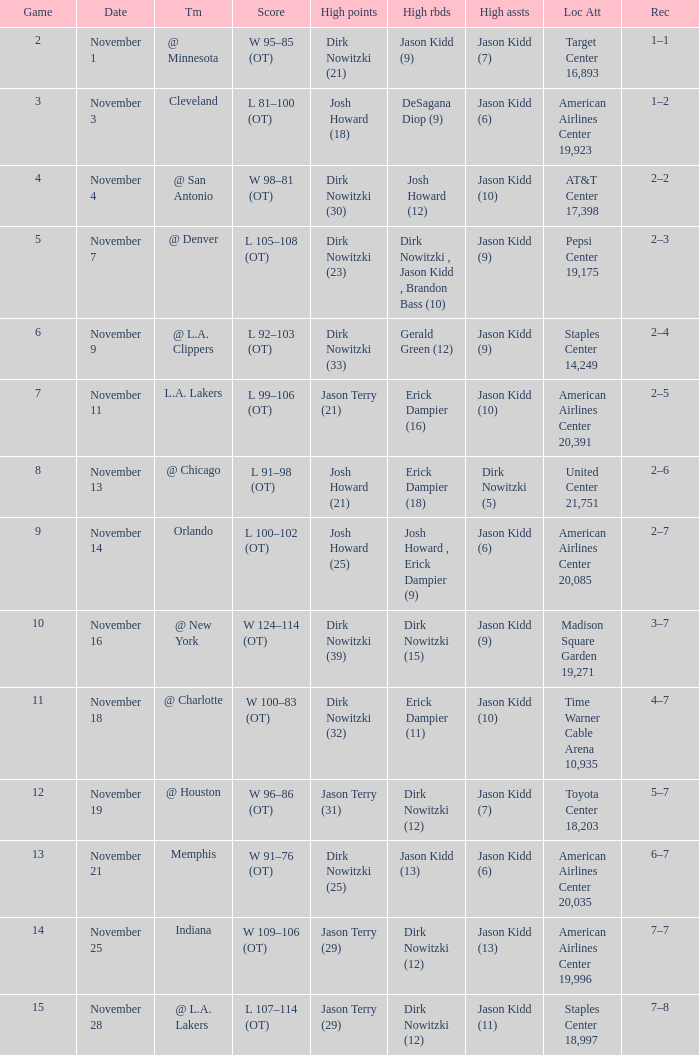What was the record on November 7? 1.0. 